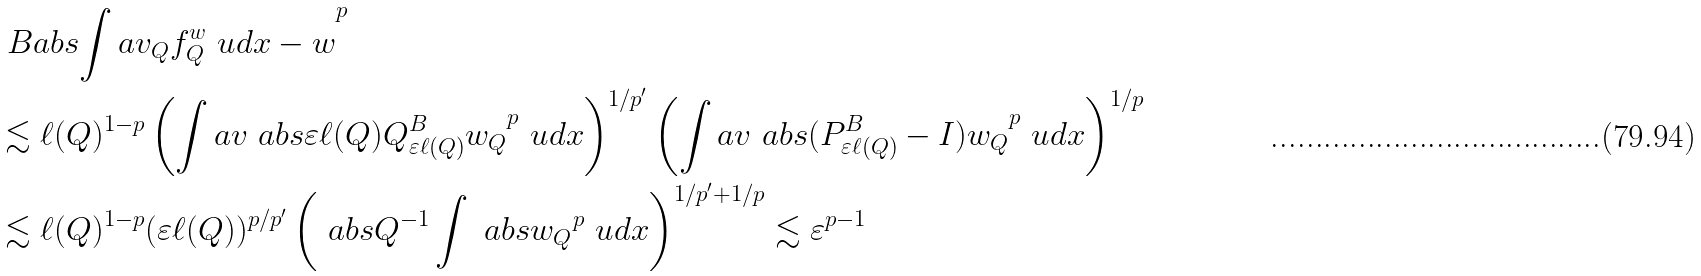Convert formula to latex. <formula><loc_0><loc_0><loc_500><loc_500>& \ B a b s { \int a v _ { Q } f ^ { w } _ { Q } \ u d x - w } ^ { p } \\ & \lesssim \ell ( Q ) ^ { 1 - p } \left ( \int a v \ a b s { \varepsilon \ell ( Q ) Q ^ { B } _ { \varepsilon \ell ( Q ) } w _ { Q } } ^ { p } \ u d x \right ) ^ { 1 / p ^ { \prime } } \left ( \int a v \ a b s { ( P ^ { B } _ { \varepsilon \ell ( Q ) } - I ) w _ { Q } } ^ { p } \ u d x \right ) ^ { 1 / p } \\ & \lesssim \ell ( Q ) ^ { 1 - p } ( \varepsilon \ell ( Q ) ) ^ { p / p ^ { \prime } } \left ( \ a b s { Q } ^ { - 1 } \int \ a b s { w _ { Q } } ^ { p } \ u d x \right ) ^ { 1 / p ^ { \prime } + 1 / p } \lesssim \varepsilon ^ { p - 1 }</formula> 